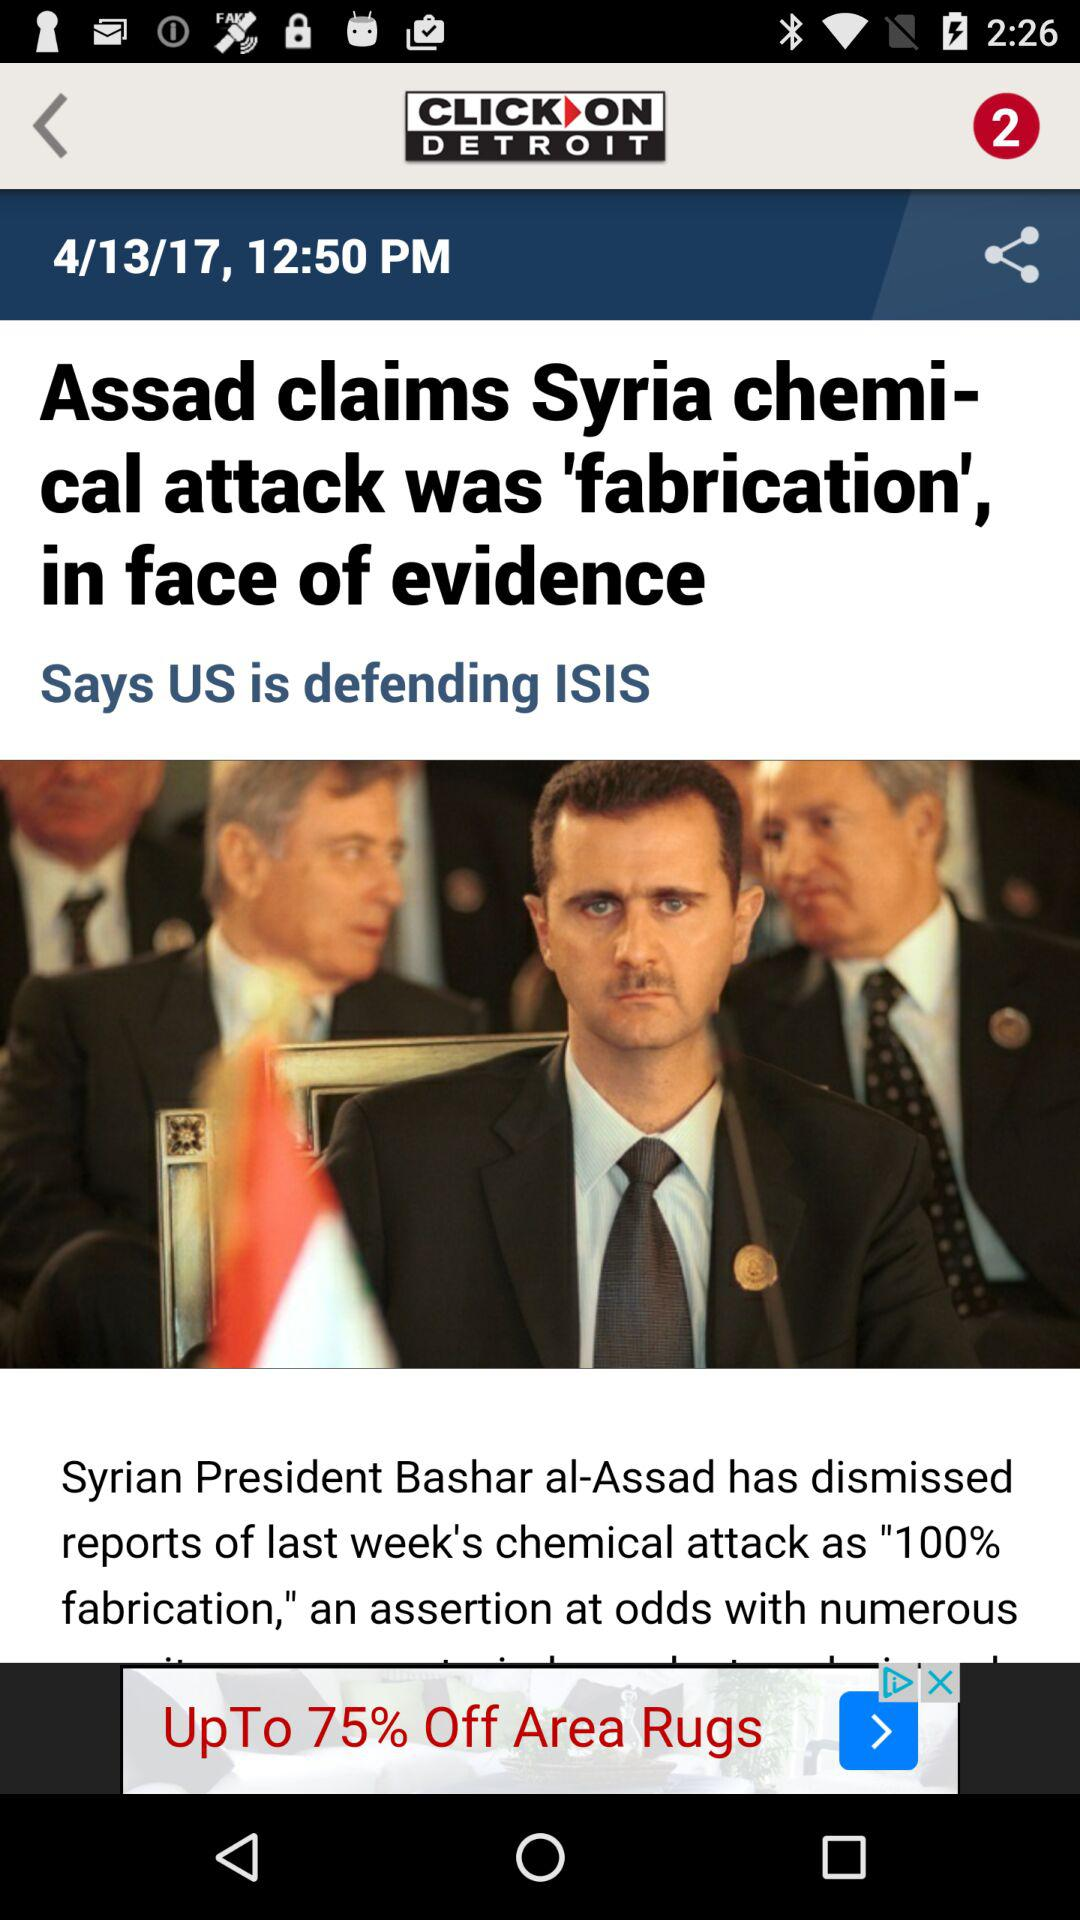What is the application name? The application name is "ClickOnDetroit - WDIV Local 4". 